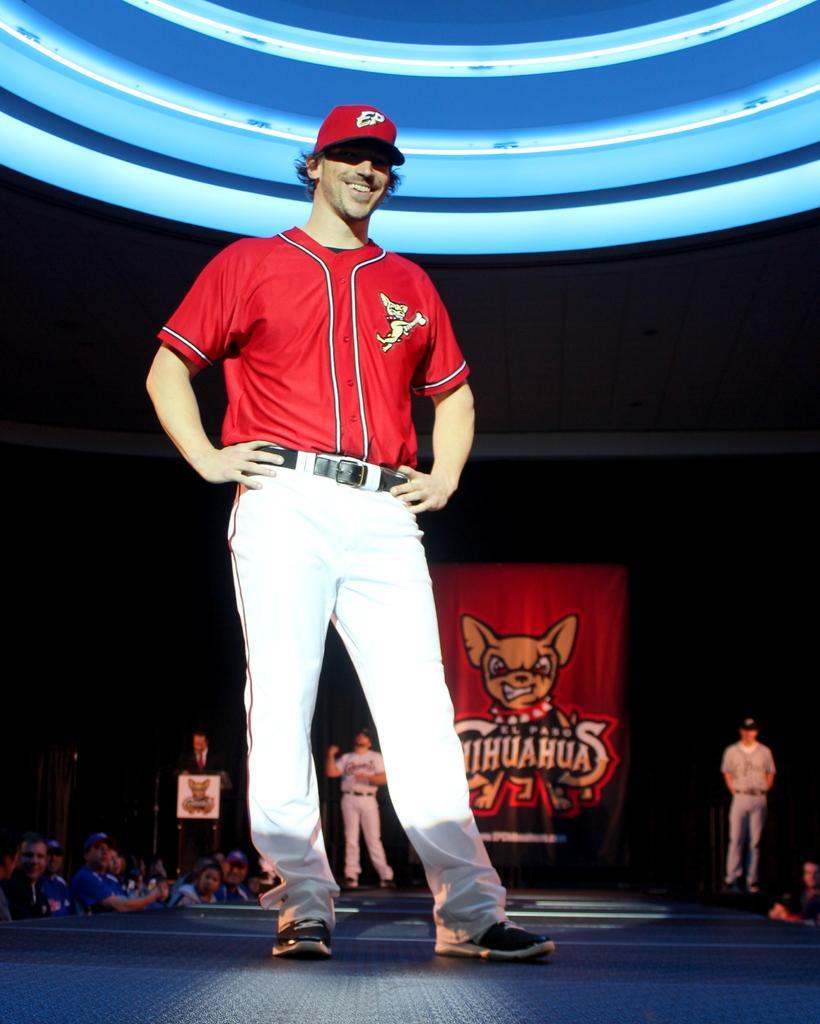Could you give a brief overview of what you see in this image? This image consists of a man wearing a red T-shirt and a red cap. At the bottom, there is a floor. In the background, there is a huge crowd. On the right, we can see a banner and a man standing. At the top, there is a light in blue color. The background is too dark. 